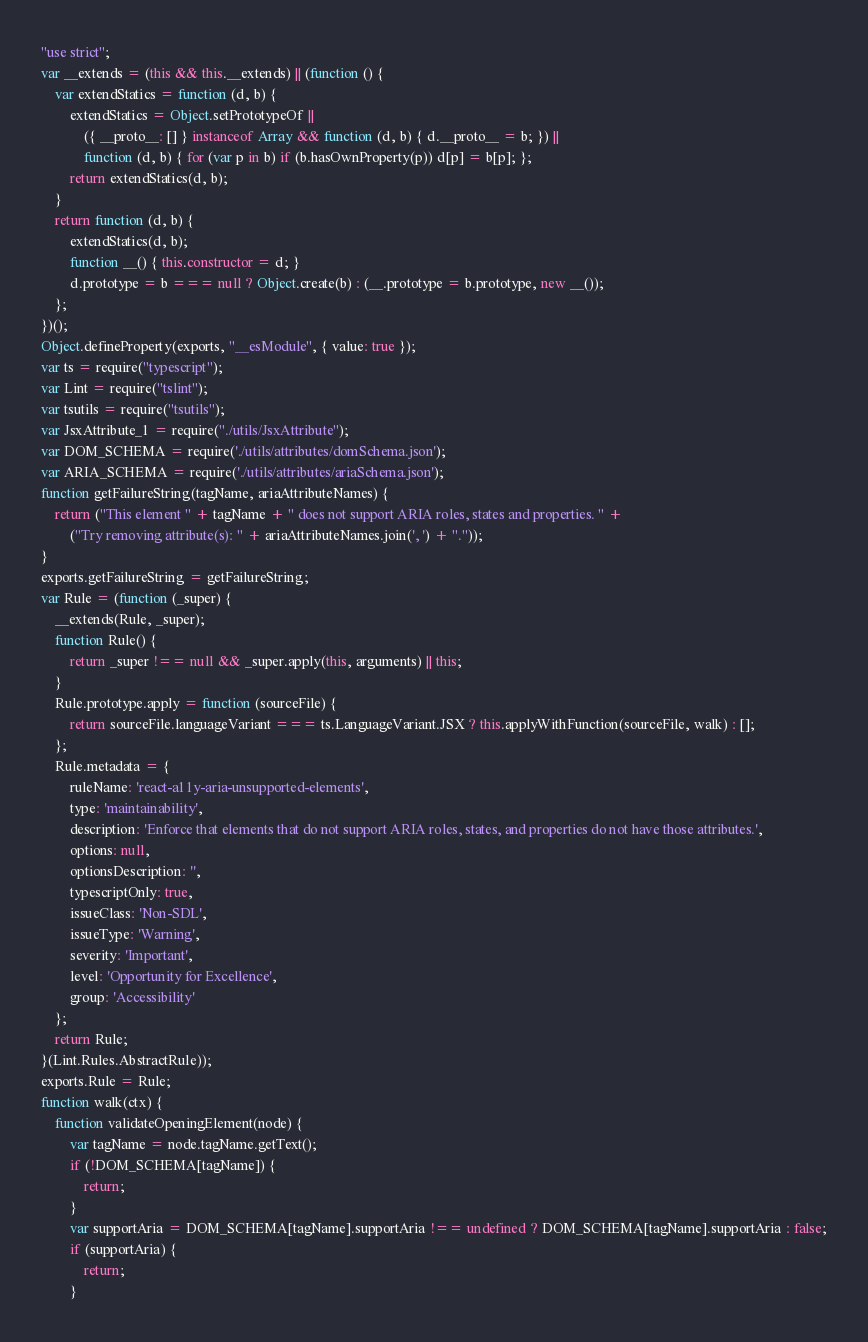Convert code to text. <code><loc_0><loc_0><loc_500><loc_500><_JavaScript_>"use strict";
var __extends = (this && this.__extends) || (function () {
    var extendStatics = function (d, b) {
        extendStatics = Object.setPrototypeOf ||
            ({ __proto__: [] } instanceof Array && function (d, b) { d.__proto__ = b; }) ||
            function (d, b) { for (var p in b) if (b.hasOwnProperty(p)) d[p] = b[p]; };
        return extendStatics(d, b);
    }
    return function (d, b) {
        extendStatics(d, b);
        function __() { this.constructor = d; }
        d.prototype = b === null ? Object.create(b) : (__.prototype = b.prototype, new __());
    };
})();
Object.defineProperty(exports, "__esModule", { value: true });
var ts = require("typescript");
var Lint = require("tslint");
var tsutils = require("tsutils");
var JsxAttribute_1 = require("./utils/JsxAttribute");
var DOM_SCHEMA = require('./utils/attributes/domSchema.json');
var ARIA_SCHEMA = require('./utils/attributes/ariaSchema.json');
function getFailureString(tagName, ariaAttributeNames) {
    return ("This element " + tagName + " does not support ARIA roles, states and properties. " +
        ("Try removing attribute(s): " + ariaAttributeNames.join(', ') + "."));
}
exports.getFailureString = getFailureString;
var Rule = (function (_super) {
    __extends(Rule, _super);
    function Rule() {
        return _super !== null && _super.apply(this, arguments) || this;
    }
    Rule.prototype.apply = function (sourceFile) {
        return sourceFile.languageVariant === ts.LanguageVariant.JSX ? this.applyWithFunction(sourceFile, walk) : [];
    };
    Rule.metadata = {
        ruleName: 'react-a11y-aria-unsupported-elements',
        type: 'maintainability',
        description: 'Enforce that elements that do not support ARIA roles, states, and properties do not have those attributes.',
        options: null,
        optionsDescription: '',
        typescriptOnly: true,
        issueClass: 'Non-SDL',
        issueType: 'Warning',
        severity: 'Important',
        level: 'Opportunity for Excellence',
        group: 'Accessibility'
    };
    return Rule;
}(Lint.Rules.AbstractRule));
exports.Rule = Rule;
function walk(ctx) {
    function validateOpeningElement(node) {
        var tagName = node.tagName.getText();
        if (!DOM_SCHEMA[tagName]) {
            return;
        }
        var supportAria = DOM_SCHEMA[tagName].supportAria !== undefined ? DOM_SCHEMA[tagName].supportAria : false;
        if (supportAria) {
            return;
        }</code> 